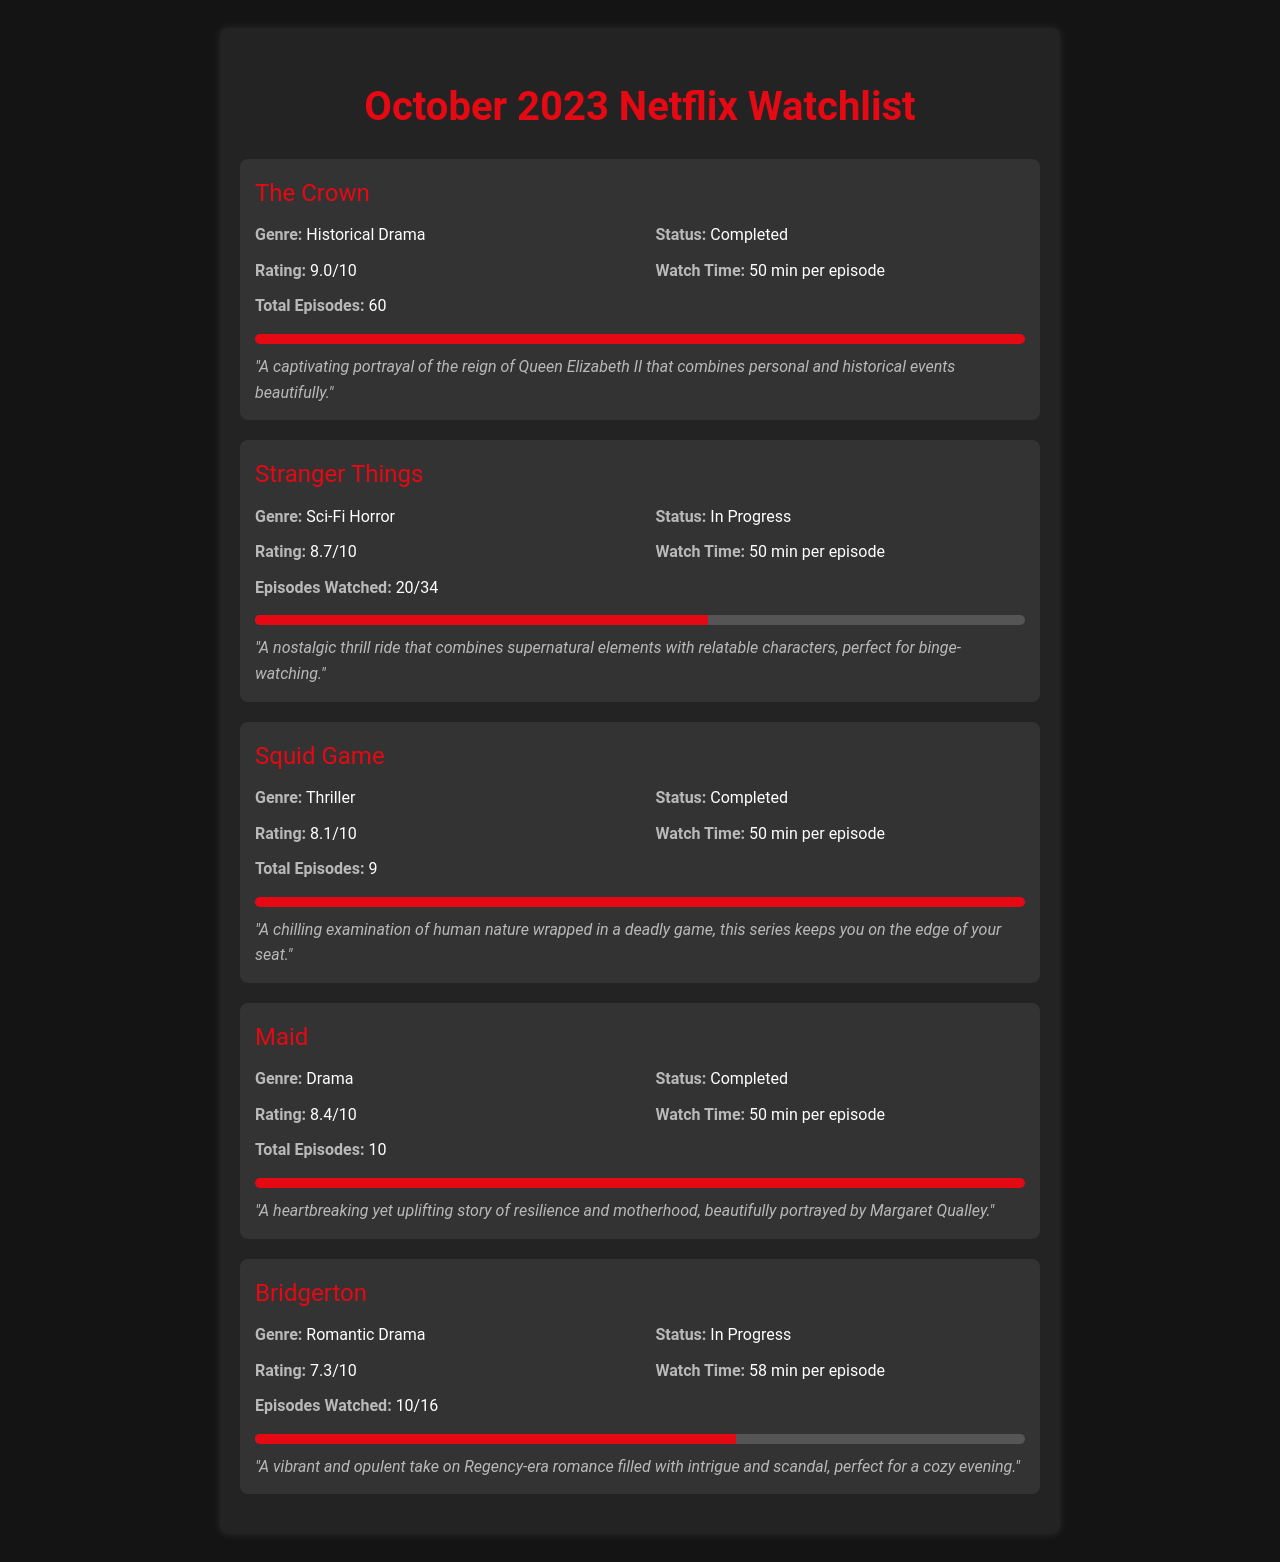What is the status of "The Crown"? The status is mentioned in the document, indicating whether the show is completed or in progress.
Answer: Completed What is the rating of "Stranger Things"? The rating is specified in the show info section for "Stranger Things".
Answer: 8.7/10 How many episodes are there in "Squid Game"? The total number of episodes for "Squid Game" is listed in the document.
Answer: 9 What genre is "Maid"? The genre is detailed in the show info section of "Maid".
Answer: Drama What percent of "Bridgerton" has been watched? The progress bar indicates the percentage of "Bridgerton" that has been watched based on the episodes viewed.
Answer: 62.5% Which show has the highest rating? The highest rating can be identified by comparing the ratings from all the shows listed in the document.
Answer: 9.0/10 How many episodes has the user watched of "Stranger Things"? The document provides specific figures regarding episodes watched for "Stranger Things".
Answer: 20/34 Which show is currently in progress that has the lowest rating? Reasoning over the status and ratings of the shows in progress will determine the show.
Answer: Bridgerton What is the watch time for each episode of "Maid"? The watch time for episodes of "Maid" is mentioned in its show details.
Answer: 50 min per episode 